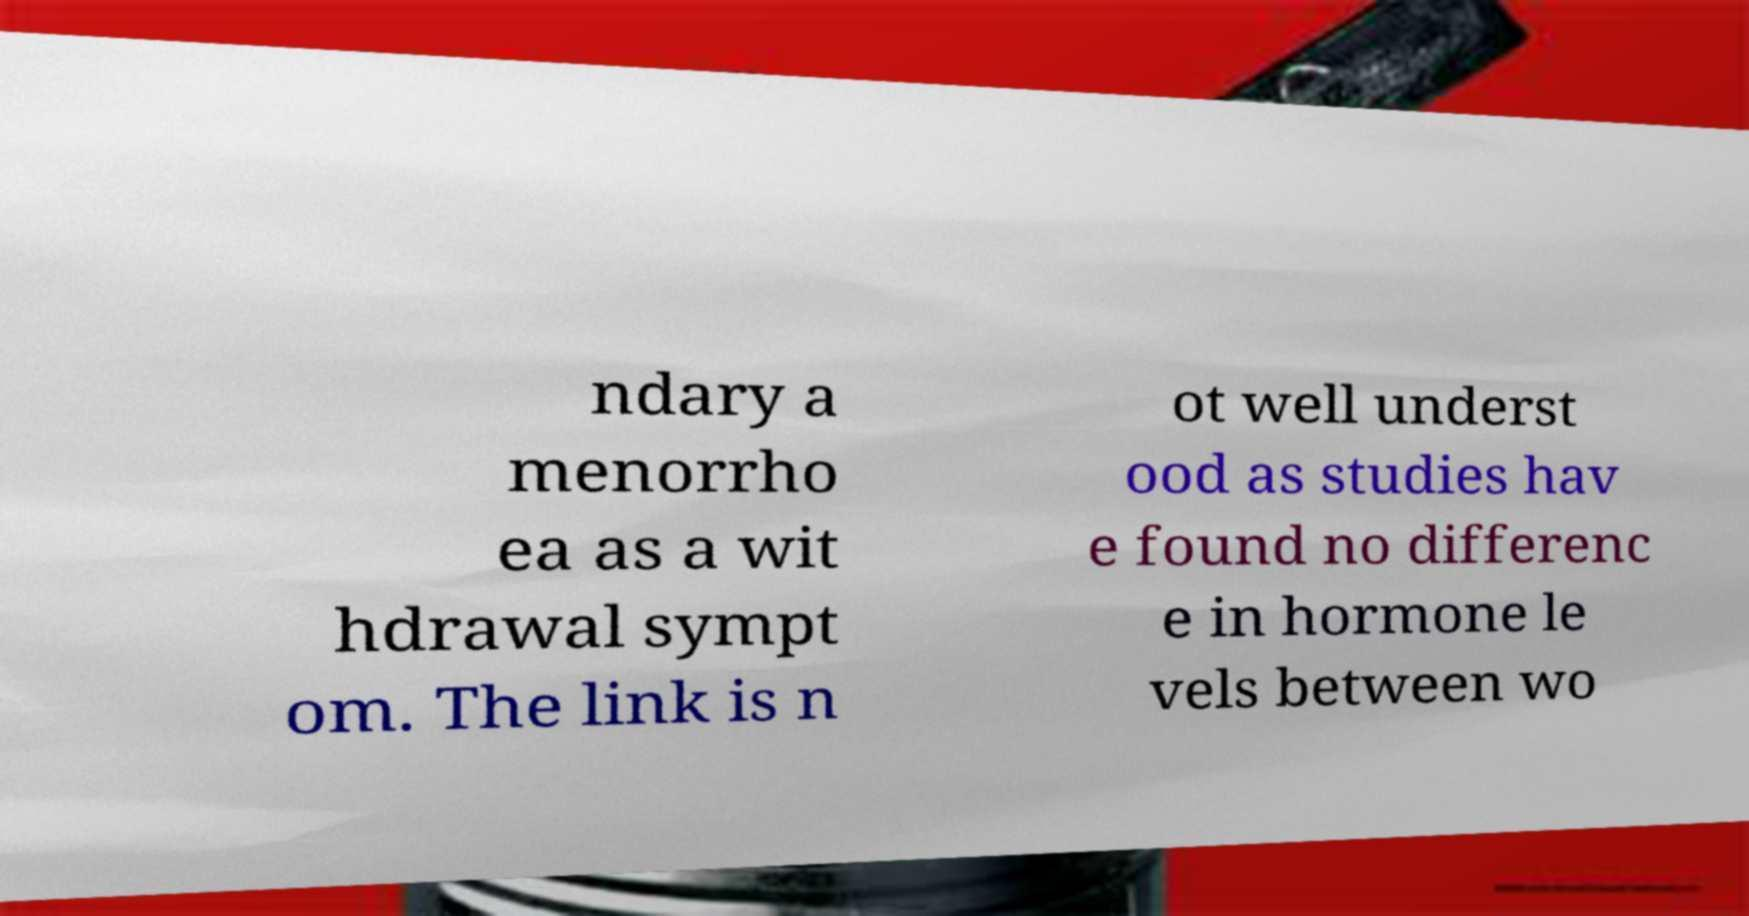Please identify and transcribe the text found in this image. ndary a menorrho ea as a wit hdrawal sympt om. The link is n ot well underst ood as studies hav e found no differenc e in hormone le vels between wo 